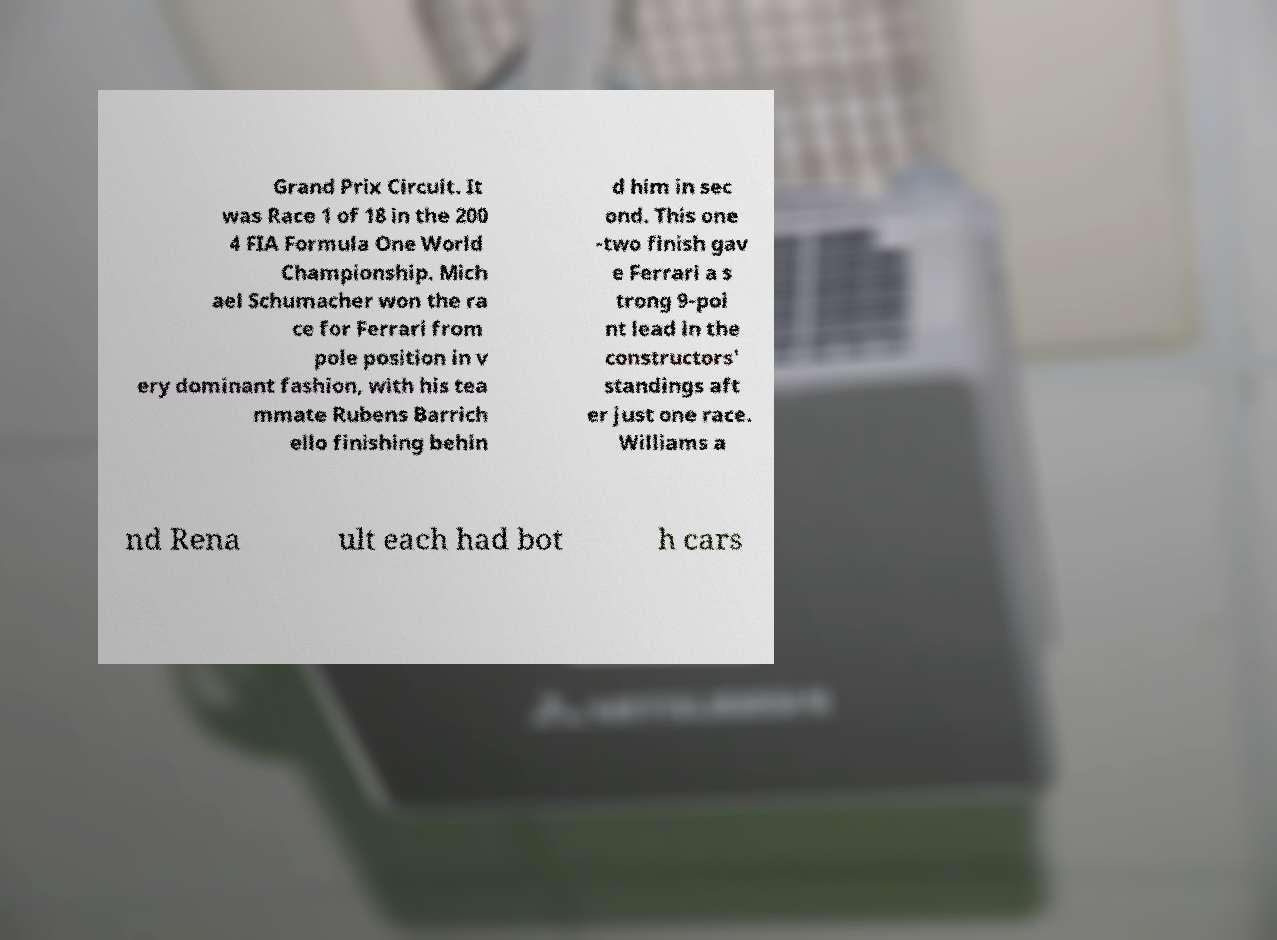Please identify and transcribe the text found in this image. Grand Prix Circuit. It was Race 1 of 18 in the 200 4 FIA Formula One World Championship. Mich ael Schumacher won the ra ce for Ferrari from pole position in v ery dominant fashion, with his tea mmate Rubens Barrich ello finishing behin d him in sec ond. This one -two finish gav e Ferrari a s trong 9-poi nt lead in the constructors' standings aft er just one race. Williams a nd Rena ult each had bot h cars 